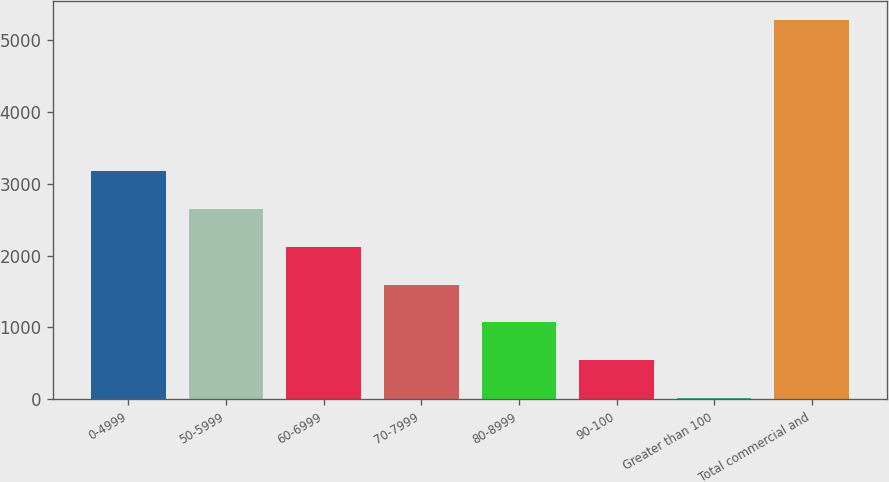Convert chart. <chart><loc_0><loc_0><loc_500><loc_500><bar_chart><fcel>0-4999<fcel>50-5999<fcel>60-6999<fcel>70-7999<fcel>80-8999<fcel>90-100<fcel>Greater than 100<fcel>Total commercial and<nl><fcel>3176.8<fcel>2650<fcel>2123.2<fcel>1596.4<fcel>1069.6<fcel>542.8<fcel>16<fcel>5284<nl></chart> 